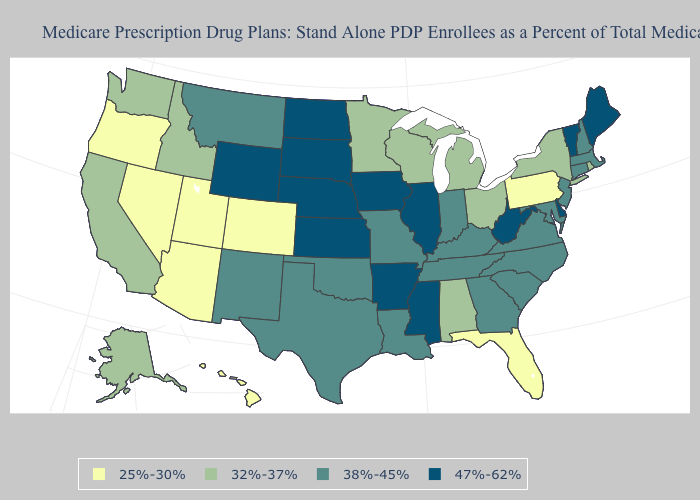What is the lowest value in the USA?
Answer briefly. 25%-30%. What is the value of Illinois?
Write a very short answer. 47%-62%. What is the value of Tennessee?
Keep it brief. 38%-45%. Which states have the lowest value in the Northeast?
Answer briefly. Pennsylvania. Name the states that have a value in the range 47%-62%?
Short answer required. Arkansas, Delaware, Iowa, Illinois, Kansas, Maine, Mississippi, North Dakota, Nebraska, South Dakota, Vermont, West Virginia, Wyoming. Among the states that border Wyoming , which have the highest value?
Give a very brief answer. Nebraska, South Dakota. What is the value of South Carolina?
Quick response, please. 38%-45%. What is the value of Vermont?
Concise answer only. 47%-62%. Among the states that border Nebraska , which have the lowest value?
Short answer required. Colorado. Name the states that have a value in the range 32%-37%?
Give a very brief answer. Alaska, Alabama, California, Idaho, Michigan, Minnesota, New York, Ohio, Rhode Island, Washington, Wisconsin. Name the states that have a value in the range 32%-37%?
Be succinct. Alaska, Alabama, California, Idaho, Michigan, Minnesota, New York, Ohio, Rhode Island, Washington, Wisconsin. Among the states that border Louisiana , which have the lowest value?
Answer briefly. Texas. Name the states that have a value in the range 38%-45%?
Write a very short answer. Connecticut, Georgia, Indiana, Kentucky, Louisiana, Massachusetts, Maryland, Missouri, Montana, North Carolina, New Hampshire, New Jersey, New Mexico, Oklahoma, South Carolina, Tennessee, Texas, Virginia. What is the lowest value in the West?
Short answer required. 25%-30%. Does Washington have a higher value than Rhode Island?
Write a very short answer. No. 